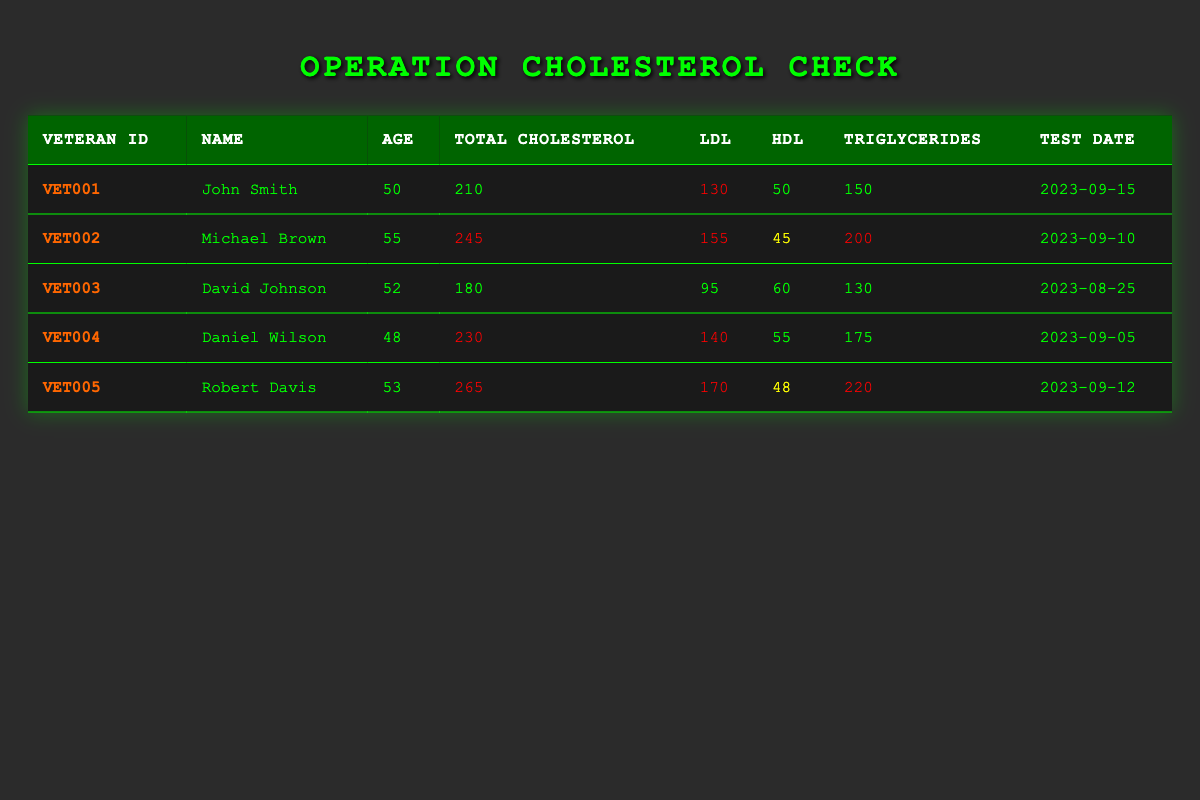What is the total cholesterol level for John Smith? John Smith's entry in the table shows that his total cholesterol level is listed as 210.
Answer: 210 Which veteran has the highest LDL level? In the table, we look at the LDL values, which are 130 for John Smith, 155 for Michael Brown, 95 for David Johnson, 140 for Daniel Wilson, and 170 for Robert Davis. Robert Davis has the highest LDL level of 170.
Answer: Robert Davis Is Michael Brown's HDL level considered low? Michael Brown's HDL is recorded as 45, which is below the recommended level of 50 for men, indicating that it is indeed low.
Answer: Yes Calculate the average triglycerides level for all veterans. We sum the triglycerides levels: 150 + 200 + 130 + 175 + 220 = 875. There are 5 veterans, so the average is 875 divided by 5, which equals 175.
Answer: 175 Who is the youngest veteran in the table? The ages listed are 50 for John Smith, 55 for Michael Brown, 52 for David Johnson, 48 for Daniel Wilson, and 53 for Robert Davis. Daniel Wilson is the youngest at 48 years old.
Answer: Daniel Wilson What percentage of veterans have total cholesterol levels above 240? In the table, total cholesterol levels above 240 are found in Michael Brown (245), Daniel Wilson (230), and Robert Davis (265). Two out of the five veterans have levels above 240, which gives us a percentage of (2/5)*100 = 40%.
Answer: 40% Are there any veterans with both triglycerides and LDL levels classified as high? Looking at the table, Robert Davis has an LDL of 170 and triglycerides of 220, both categorized as high. No other veterans have both high LDL and triglyceride levels.
Answer: Yes What is the difference in total cholesterol levels between the veteran with the highest and the veteran with the lowest? The highest total cholesterol is Robert Davis at 265 and the lowest is David Johnson at 180. The difference is 265 - 180 = 85.
Answer: 85 In the most recent test date listed, which veteran's results are considered normal? The most recent test date is September 15, 2023, for John Smith, whose total cholesterol (210), LDL (130), HDL (50), and triglycerides (150) are categorized as normal.
Answer: John Smith 